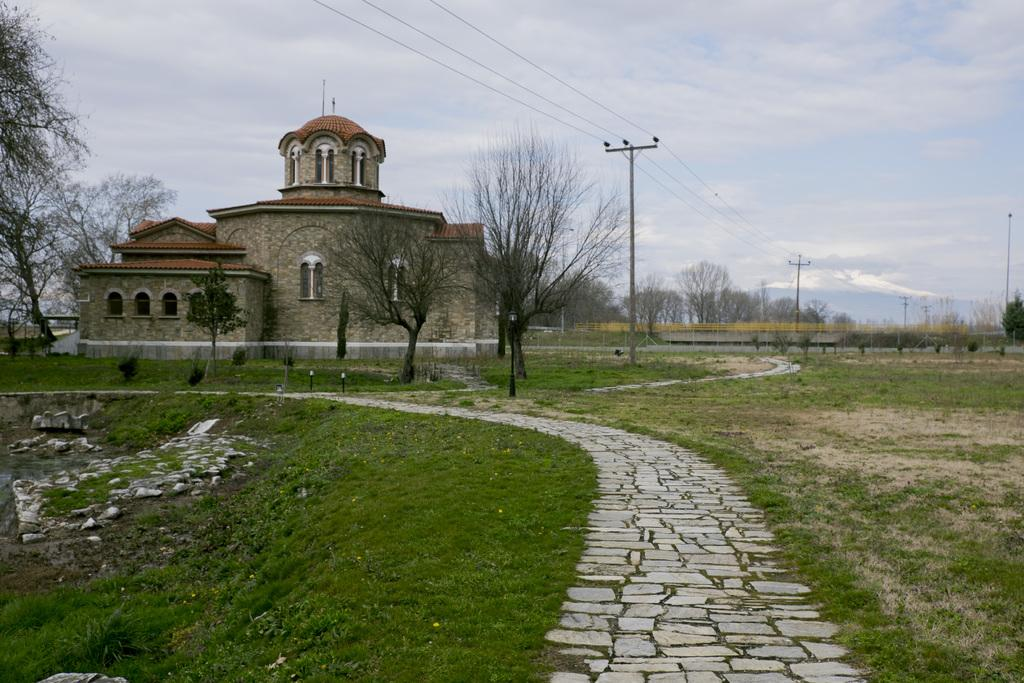What type of structure is visible in the image? There is a building with windows in the image. What can be seen on the ground in the image? The ground is visible in the image, and there is grass and a path on the ground. What type of vegetation is present in the image? There are trees in the image. What are the poles in the image used for? The poles in the image have wires on them. What is visible in the sky in the image? The sky is visible in the image, and there are clouds in the sky. What type of protest is taking place in the image? There is no protest present in the image. What instrument is the band playing in the image? There is no band present in the image. 